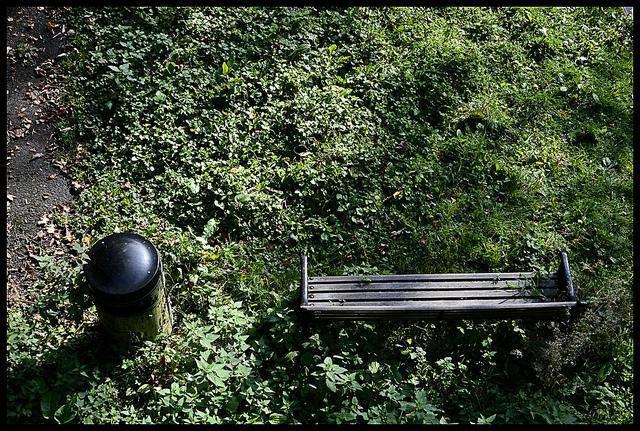How many people are pulling luggage behind them?
Give a very brief answer. 0. 